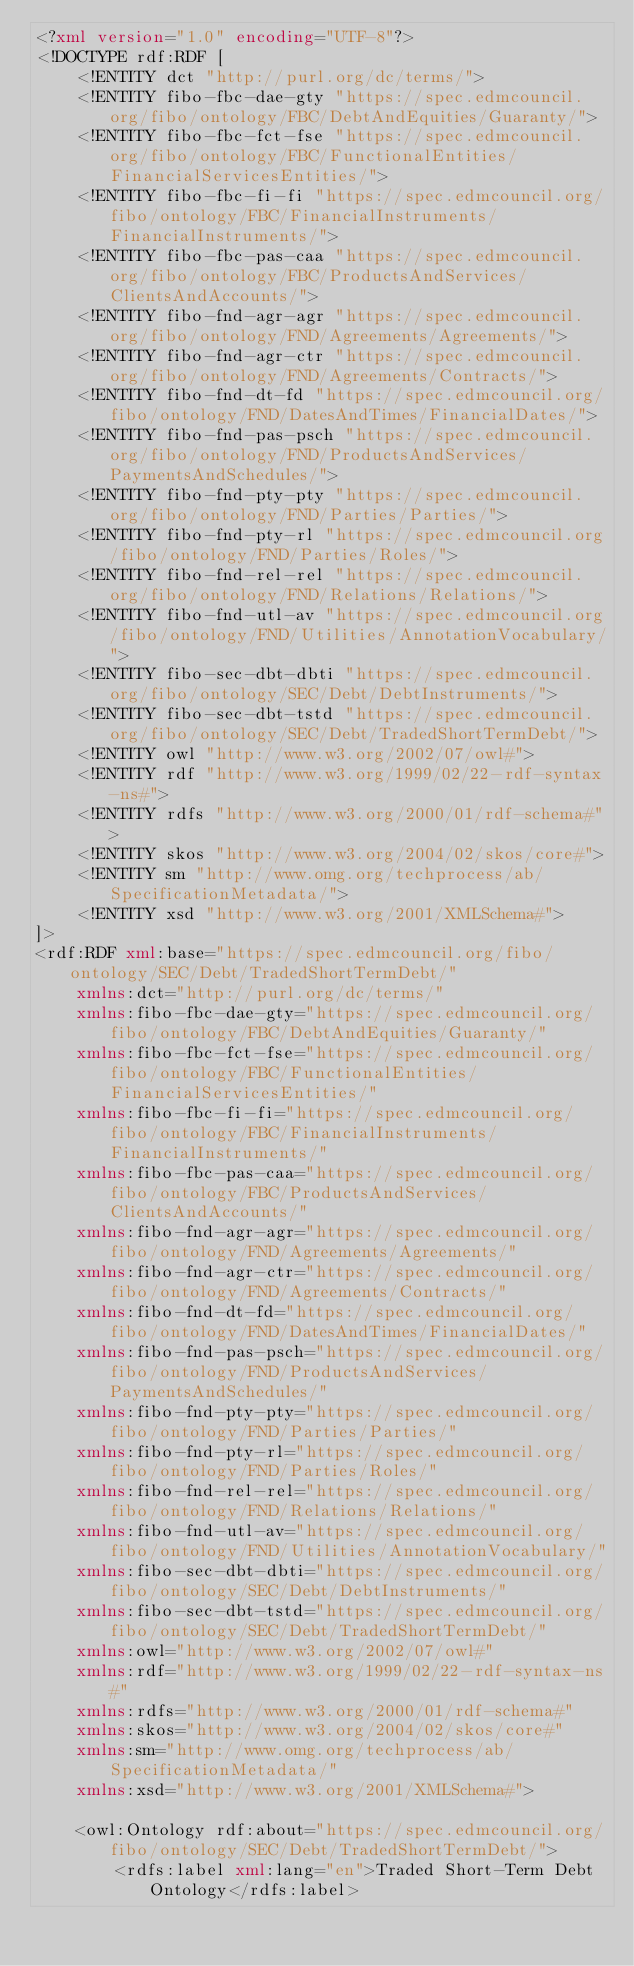Convert code to text. <code><loc_0><loc_0><loc_500><loc_500><_XML_><?xml version="1.0" encoding="UTF-8"?>
<!DOCTYPE rdf:RDF [
	<!ENTITY dct "http://purl.org/dc/terms/">
	<!ENTITY fibo-fbc-dae-gty "https://spec.edmcouncil.org/fibo/ontology/FBC/DebtAndEquities/Guaranty/">
	<!ENTITY fibo-fbc-fct-fse "https://spec.edmcouncil.org/fibo/ontology/FBC/FunctionalEntities/FinancialServicesEntities/">
	<!ENTITY fibo-fbc-fi-fi "https://spec.edmcouncil.org/fibo/ontology/FBC/FinancialInstruments/FinancialInstruments/">
	<!ENTITY fibo-fbc-pas-caa "https://spec.edmcouncil.org/fibo/ontology/FBC/ProductsAndServices/ClientsAndAccounts/">
	<!ENTITY fibo-fnd-agr-agr "https://spec.edmcouncil.org/fibo/ontology/FND/Agreements/Agreements/">
	<!ENTITY fibo-fnd-agr-ctr "https://spec.edmcouncil.org/fibo/ontology/FND/Agreements/Contracts/">
	<!ENTITY fibo-fnd-dt-fd "https://spec.edmcouncil.org/fibo/ontology/FND/DatesAndTimes/FinancialDates/">
	<!ENTITY fibo-fnd-pas-psch "https://spec.edmcouncil.org/fibo/ontology/FND/ProductsAndServices/PaymentsAndSchedules/">
	<!ENTITY fibo-fnd-pty-pty "https://spec.edmcouncil.org/fibo/ontology/FND/Parties/Parties/">
	<!ENTITY fibo-fnd-pty-rl "https://spec.edmcouncil.org/fibo/ontology/FND/Parties/Roles/">
	<!ENTITY fibo-fnd-rel-rel "https://spec.edmcouncil.org/fibo/ontology/FND/Relations/Relations/">
	<!ENTITY fibo-fnd-utl-av "https://spec.edmcouncil.org/fibo/ontology/FND/Utilities/AnnotationVocabulary/">
	<!ENTITY fibo-sec-dbt-dbti "https://spec.edmcouncil.org/fibo/ontology/SEC/Debt/DebtInstruments/">
	<!ENTITY fibo-sec-dbt-tstd "https://spec.edmcouncil.org/fibo/ontology/SEC/Debt/TradedShortTermDebt/">
	<!ENTITY owl "http://www.w3.org/2002/07/owl#">
	<!ENTITY rdf "http://www.w3.org/1999/02/22-rdf-syntax-ns#">
	<!ENTITY rdfs "http://www.w3.org/2000/01/rdf-schema#">
	<!ENTITY skos "http://www.w3.org/2004/02/skos/core#">
	<!ENTITY sm "http://www.omg.org/techprocess/ab/SpecificationMetadata/">
	<!ENTITY xsd "http://www.w3.org/2001/XMLSchema#">
]>
<rdf:RDF xml:base="https://spec.edmcouncil.org/fibo/ontology/SEC/Debt/TradedShortTermDebt/"
	xmlns:dct="http://purl.org/dc/terms/"
	xmlns:fibo-fbc-dae-gty="https://spec.edmcouncil.org/fibo/ontology/FBC/DebtAndEquities/Guaranty/"
	xmlns:fibo-fbc-fct-fse="https://spec.edmcouncil.org/fibo/ontology/FBC/FunctionalEntities/FinancialServicesEntities/"
	xmlns:fibo-fbc-fi-fi="https://spec.edmcouncil.org/fibo/ontology/FBC/FinancialInstruments/FinancialInstruments/"
	xmlns:fibo-fbc-pas-caa="https://spec.edmcouncil.org/fibo/ontology/FBC/ProductsAndServices/ClientsAndAccounts/"
	xmlns:fibo-fnd-agr-agr="https://spec.edmcouncil.org/fibo/ontology/FND/Agreements/Agreements/"
	xmlns:fibo-fnd-agr-ctr="https://spec.edmcouncil.org/fibo/ontology/FND/Agreements/Contracts/"
	xmlns:fibo-fnd-dt-fd="https://spec.edmcouncil.org/fibo/ontology/FND/DatesAndTimes/FinancialDates/"
	xmlns:fibo-fnd-pas-psch="https://spec.edmcouncil.org/fibo/ontology/FND/ProductsAndServices/PaymentsAndSchedules/"
	xmlns:fibo-fnd-pty-pty="https://spec.edmcouncil.org/fibo/ontology/FND/Parties/Parties/"
	xmlns:fibo-fnd-pty-rl="https://spec.edmcouncil.org/fibo/ontology/FND/Parties/Roles/"
	xmlns:fibo-fnd-rel-rel="https://spec.edmcouncil.org/fibo/ontology/FND/Relations/Relations/"
	xmlns:fibo-fnd-utl-av="https://spec.edmcouncil.org/fibo/ontology/FND/Utilities/AnnotationVocabulary/"
	xmlns:fibo-sec-dbt-dbti="https://spec.edmcouncil.org/fibo/ontology/SEC/Debt/DebtInstruments/"
	xmlns:fibo-sec-dbt-tstd="https://spec.edmcouncil.org/fibo/ontology/SEC/Debt/TradedShortTermDebt/"
	xmlns:owl="http://www.w3.org/2002/07/owl#"
	xmlns:rdf="http://www.w3.org/1999/02/22-rdf-syntax-ns#"
	xmlns:rdfs="http://www.w3.org/2000/01/rdf-schema#"
	xmlns:skos="http://www.w3.org/2004/02/skos/core#"
	xmlns:sm="http://www.omg.org/techprocess/ab/SpecificationMetadata/"
	xmlns:xsd="http://www.w3.org/2001/XMLSchema#">
	
	<owl:Ontology rdf:about="https://spec.edmcouncil.org/fibo/ontology/SEC/Debt/TradedShortTermDebt/">
		<rdfs:label xml:lang="en">Traded Short-Term Debt Ontology</rdfs:label></code> 